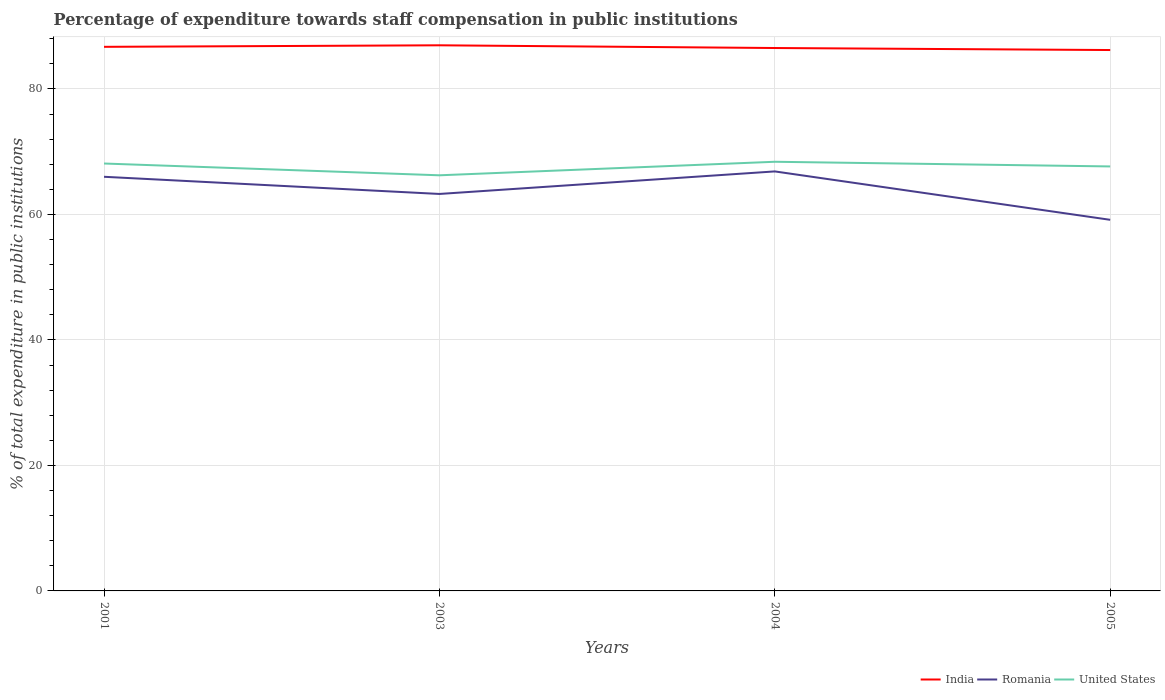How many different coloured lines are there?
Give a very brief answer. 3. Does the line corresponding to Romania intersect with the line corresponding to United States?
Give a very brief answer. No. Is the number of lines equal to the number of legend labels?
Provide a short and direct response. Yes. Across all years, what is the maximum percentage of expenditure towards staff compensation in United States?
Offer a terse response. 66.24. What is the total percentage of expenditure towards staff compensation in United States in the graph?
Ensure brevity in your answer.  -1.41. What is the difference between the highest and the second highest percentage of expenditure towards staff compensation in India?
Make the answer very short. 0.75. How many years are there in the graph?
Provide a succinct answer. 4. What is the difference between two consecutive major ticks on the Y-axis?
Offer a very short reply. 20. Does the graph contain any zero values?
Provide a succinct answer. No. Does the graph contain grids?
Ensure brevity in your answer.  Yes. How are the legend labels stacked?
Ensure brevity in your answer.  Horizontal. What is the title of the graph?
Provide a short and direct response. Percentage of expenditure towards staff compensation in public institutions. What is the label or title of the Y-axis?
Make the answer very short. % of total expenditure in public institutions. What is the % of total expenditure in public institutions in India in 2001?
Offer a terse response. 86.71. What is the % of total expenditure in public institutions in Romania in 2001?
Your answer should be compact. 66. What is the % of total expenditure in public institutions of United States in 2001?
Provide a succinct answer. 68.12. What is the % of total expenditure in public institutions in India in 2003?
Offer a very short reply. 86.95. What is the % of total expenditure in public institutions of Romania in 2003?
Provide a short and direct response. 63.27. What is the % of total expenditure in public institutions of United States in 2003?
Offer a very short reply. 66.24. What is the % of total expenditure in public institutions in India in 2004?
Keep it short and to the point. 86.52. What is the % of total expenditure in public institutions in Romania in 2004?
Your answer should be compact. 66.86. What is the % of total expenditure in public institutions of United States in 2004?
Ensure brevity in your answer.  68.39. What is the % of total expenditure in public institutions in India in 2005?
Your answer should be compact. 86.2. What is the % of total expenditure in public institutions in Romania in 2005?
Keep it short and to the point. 59.14. What is the % of total expenditure in public institutions in United States in 2005?
Your answer should be compact. 67.65. Across all years, what is the maximum % of total expenditure in public institutions of India?
Ensure brevity in your answer.  86.95. Across all years, what is the maximum % of total expenditure in public institutions of Romania?
Your answer should be compact. 66.86. Across all years, what is the maximum % of total expenditure in public institutions in United States?
Offer a very short reply. 68.39. Across all years, what is the minimum % of total expenditure in public institutions in India?
Give a very brief answer. 86.2. Across all years, what is the minimum % of total expenditure in public institutions of Romania?
Your response must be concise. 59.14. Across all years, what is the minimum % of total expenditure in public institutions in United States?
Offer a terse response. 66.24. What is the total % of total expenditure in public institutions of India in the graph?
Give a very brief answer. 346.39. What is the total % of total expenditure in public institutions of Romania in the graph?
Your answer should be compact. 255.27. What is the total % of total expenditure in public institutions in United States in the graph?
Your answer should be compact. 270.4. What is the difference between the % of total expenditure in public institutions in India in 2001 and that in 2003?
Offer a very short reply. -0.24. What is the difference between the % of total expenditure in public institutions of Romania in 2001 and that in 2003?
Your response must be concise. 2.74. What is the difference between the % of total expenditure in public institutions in United States in 2001 and that in 2003?
Ensure brevity in your answer.  1.88. What is the difference between the % of total expenditure in public institutions of India in 2001 and that in 2004?
Your answer should be very brief. 0.19. What is the difference between the % of total expenditure in public institutions of Romania in 2001 and that in 2004?
Provide a short and direct response. -0.86. What is the difference between the % of total expenditure in public institutions of United States in 2001 and that in 2004?
Offer a terse response. -0.28. What is the difference between the % of total expenditure in public institutions in India in 2001 and that in 2005?
Give a very brief answer. 0.51. What is the difference between the % of total expenditure in public institutions of Romania in 2001 and that in 2005?
Keep it short and to the point. 6.86. What is the difference between the % of total expenditure in public institutions in United States in 2001 and that in 2005?
Your response must be concise. 0.47. What is the difference between the % of total expenditure in public institutions of India in 2003 and that in 2004?
Keep it short and to the point. 0.43. What is the difference between the % of total expenditure in public institutions in Romania in 2003 and that in 2004?
Your answer should be very brief. -3.59. What is the difference between the % of total expenditure in public institutions in United States in 2003 and that in 2004?
Give a very brief answer. -2.16. What is the difference between the % of total expenditure in public institutions in India in 2003 and that in 2005?
Make the answer very short. 0.75. What is the difference between the % of total expenditure in public institutions in Romania in 2003 and that in 2005?
Make the answer very short. 4.12. What is the difference between the % of total expenditure in public institutions in United States in 2003 and that in 2005?
Provide a succinct answer. -1.41. What is the difference between the % of total expenditure in public institutions in India in 2004 and that in 2005?
Offer a terse response. 0.32. What is the difference between the % of total expenditure in public institutions of Romania in 2004 and that in 2005?
Ensure brevity in your answer.  7.71. What is the difference between the % of total expenditure in public institutions in United States in 2004 and that in 2005?
Your answer should be compact. 0.75. What is the difference between the % of total expenditure in public institutions of India in 2001 and the % of total expenditure in public institutions of Romania in 2003?
Your response must be concise. 23.45. What is the difference between the % of total expenditure in public institutions in India in 2001 and the % of total expenditure in public institutions in United States in 2003?
Your response must be concise. 20.47. What is the difference between the % of total expenditure in public institutions in Romania in 2001 and the % of total expenditure in public institutions in United States in 2003?
Ensure brevity in your answer.  -0.24. What is the difference between the % of total expenditure in public institutions of India in 2001 and the % of total expenditure in public institutions of Romania in 2004?
Provide a short and direct response. 19.85. What is the difference between the % of total expenditure in public institutions in India in 2001 and the % of total expenditure in public institutions in United States in 2004?
Offer a terse response. 18.32. What is the difference between the % of total expenditure in public institutions of Romania in 2001 and the % of total expenditure in public institutions of United States in 2004?
Give a very brief answer. -2.39. What is the difference between the % of total expenditure in public institutions in India in 2001 and the % of total expenditure in public institutions in Romania in 2005?
Provide a short and direct response. 27.57. What is the difference between the % of total expenditure in public institutions of India in 2001 and the % of total expenditure in public institutions of United States in 2005?
Your answer should be very brief. 19.06. What is the difference between the % of total expenditure in public institutions in Romania in 2001 and the % of total expenditure in public institutions in United States in 2005?
Offer a terse response. -1.65. What is the difference between the % of total expenditure in public institutions in India in 2003 and the % of total expenditure in public institutions in Romania in 2004?
Your answer should be compact. 20.1. What is the difference between the % of total expenditure in public institutions of India in 2003 and the % of total expenditure in public institutions of United States in 2004?
Offer a very short reply. 18.56. What is the difference between the % of total expenditure in public institutions in Romania in 2003 and the % of total expenditure in public institutions in United States in 2004?
Keep it short and to the point. -5.13. What is the difference between the % of total expenditure in public institutions of India in 2003 and the % of total expenditure in public institutions of Romania in 2005?
Offer a terse response. 27.81. What is the difference between the % of total expenditure in public institutions in India in 2003 and the % of total expenditure in public institutions in United States in 2005?
Your answer should be very brief. 19.31. What is the difference between the % of total expenditure in public institutions in Romania in 2003 and the % of total expenditure in public institutions in United States in 2005?
Your response must be concise. -4.38. What is the difference between the % of total expenditure in public institutions in India in 2004 and the % of total expenditure in public institutions in Romania in 2005?
Provide a succinct answer. 27.38. What is the difference between the % of total expenditure in public institutions of India in 2004 and the % of total expenditure in public institutions of United States in 2005?
Ensure brevity in your answer.  18.87. What is the difference between the % of total expenditure in public institutions in Romania in 2004 and the % of total expenditure in public institutions in United States in 2005?
Offer a terse response. -0.79. What is the average % of total expenditure in public institutions in India per year?
Provide a succinct answer. 86.6. What is the average % of total expenditure in public institutions of Romania per year?
Offer a terse response. 63.82. What is the average % of total expenditure in public institutions in United States per year?
Ensure brevity in your answer.  67.6. In the year 2001, what is the difference between the % of total expenditure in public institutions in India and % of total expenditure in public institutions in Romania?
Offer a terse response. 20.71. In the year 2001, what is the difference between the % of total expenditure in public institutions in India and % of total expenditure in public institutions in United States?
Provide a short and direct response. 18.59. In the year 2001, what is the difference between the % of total expenditure in public institutions in Romania and % of total expenditure in public institutions in United States?
Ensure brevity in your answer.  -2.12. In the year 2003, what is the difference between the % of total expenditure in public institutions of India and % of total expenditure in public institutions of Romania?
Your answer should be very brief. 23.69. In the year 2003, what is the difference between the % of total expenditure in public institutions in India and % of total expenditure in public institutions in United States?
Provide a succinct answer. 20.72. In the year 2003, what is the difference between the % of total expenditure in public institutions of Romania and % of total expenditure in public institutions of United States?
Give a very brief answer. -2.97. In the year 2004, what is the difference between the % of total expenditure in public institutions in India and % of total expenditure in public institutions in Romania?
Ensure brevity in your answer.  19.67. In the year 2004, what is the difference between the % of total expenditure in public institutions of India and % of total expenditure in public institutions of United States?
Provide a short and direct response. 18.13. In the year 2004, what is the difference between the % of total expenditure in public institutions of Romania and % of total expenditure in public institutions of United States?
Offer a very short reply. -1.54. In the year 2005, what is the difference between the % of total expenditure in public institutions of India and % of total expenditure in public institutions of Romania?
Provide a succinct answer. 27.06. In the year 2005, what is the difference between the % of total expenditure in public institutions of India and % of total expenditure in public institutions of United States?
Your response must be concise. 18.55. In the year 2005, what is the difference between the % of total expenditure in public institutions in Romania and % of total expenditure in public institutions in United States?
Provide a short and direct response. -8.51. What is the ratio of the % of total expenditure in public institutions of India in 2001 to that in 2003?
Ensure brevity in your answer.  1. What is the ratio of the % of total expenditure in public institutions of Romania in 2001 to that in 2003?
Offer a terse response. 1.04. What is the ratio of the % of total expenditure in public institutions in United States in 2001 to that in 2003?
Offer a terse response. 1.03. What is the ratio of the % of total expenditure in public institutions of India in 2001 to that in 2004?
Your answer should be compact. 1. What is the ratio of the % of total expenditure in public institutions in Romania in 2001 to that in 2004?
Your response must be concise. 0.99. What is the ratio of the % of total expenditure in public institutions of India in 2001 to that in 2005?
Ensure brevity in your answer.  1.01. What is the ratio of the % of total expenditure in public institutions in Romania in 2001 to that in 2005?
Keep it short and to the point. 1.12. What is the ratio of the % of total expenditure in public institutions of United States in 2001 to that in 2005?
Keep it short and to the point. 1.01. What is the ratio of the % of total expenditure in public institutions of India in 2003 to that in 2004?
Your response must be concise. 1. What is the ratio of the % of total expenditure in public institutions in Romania in 2003 to that in 2004?
Your response must be concise. 0.95. What is the ratio of the % of total expenditure in public institutions of United States in 2003 to that in 2004?
Offer a very short reply. 0.97. What is the ratio of the % of total expenditure in public institutions in India in 2003 to that in 2005?
Give a very brief answer. 1.01. What is the ratio of the % of total expenditure in public institutions in Romania in 2003 to that in 2005?
Your response must be concise. 1.07. What is the ratio of the % of total expenditure in public institutions of United States in 2003 to that in 2005?
Your answer should be very brief. 0.98. What is the ratio of the % of total expenditure in public institutions in India in 2004 to that in 2005?
Offer a very short reply. 1. What is the ratio of the % of total expenditure in public institutions of Romania in 2004 to that in 2005?
Give a very brief answer. 1.13. What is the ratio of the % of total expenditure in public institutions in United States in 2004 to that in 2005?
Make the answer very short. 1.01. What is the difference between the highest and the second highest % of total expenditure in public institutions in India?
Your answer should be compact. 0.24. What is the difference between the highest and the second highest % of total expenditure in public institutions of Romania?
Make the answer very short. 0.86. What is the difference between the highest and the second highest % of total expenditure in public institutions in United States?
Your response must be concise. 0.28. What is the difference between the highest and the lowest % of total expenditure in public institutions in India?
Offer a terse response. 0.75. What is the difference between the highest and the lowest % of total expenditure in public institutions in Romania?
Your answer should be very brief. 7.71. What is the difference between the highest and the lowest % of total expenditure in public institutions in United States?
Make the answer very short. 2.16. 